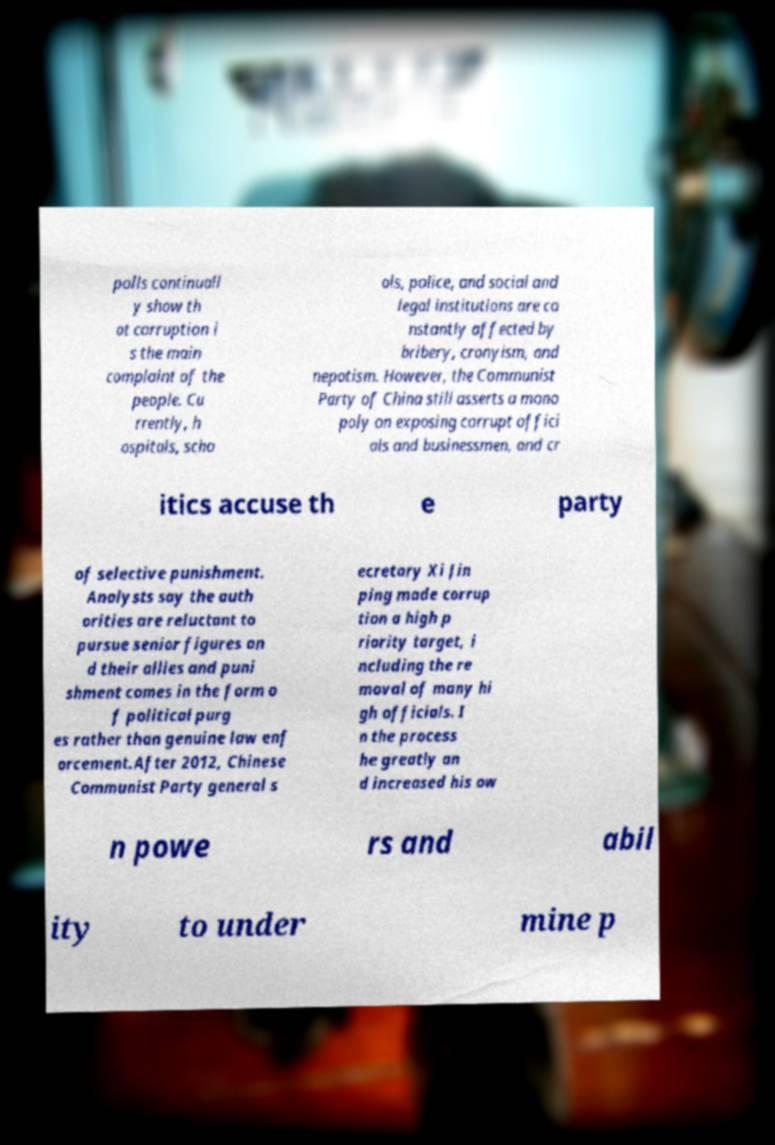For documentation purposes, I need the text within this image transcribed. Could you provide that? polls continuall y show th at corruption i s the main complaint of the people. Cu rrently, h ospitals, scho ols, police, and social and legal institutions are co nstantly affected by bribery, cronyism, and nepotism. However, the Communist Party of China still asserts a mono poly on exposing corrupt offici als and businessmen, and cr itics accuse th e party of selective punishment. Analysts say the auth orities are reluctant to pursue senior figures an d their allies and puni shment comes in the form o f political purg es rather than genuine law enf orcement.After 2012, Chinese Communist Party general s ecretary Xi Jin ping made corrup tion a high p riority target, i ncluding the re moval of many hi gh officials. I n the process he greatly an d increased his ow n powe rs and abil ity to under mine p 